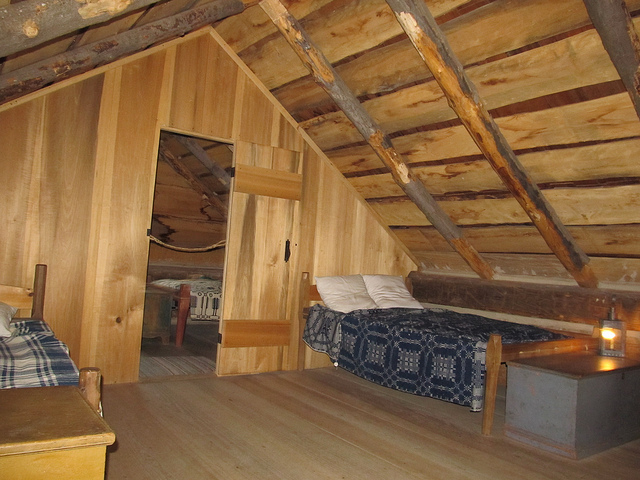Can you describe the lighting in this room? The room’s lighting appears to be soft and ambient, achieved through the use of candles placed in lanterns. This kind of lighting gives the space a cozy and inviting atmosphere, in harmony with the wooden interior. Does the candle light provide enough illumination? The candle light offers a muted glow that is likely sufficient for creating a relaxed setting, but additional lighting might be necessary for activities that require good visibility, such as reading or writing. 